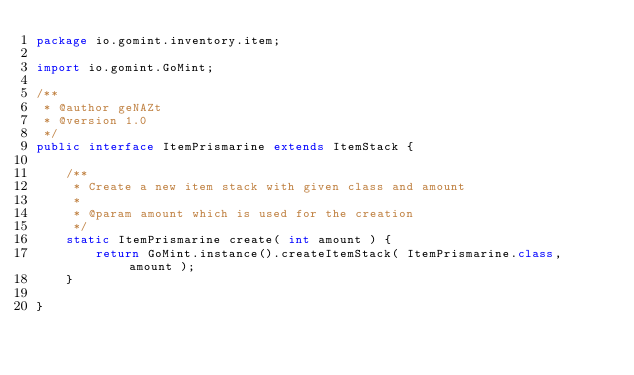Convert code to text. <code><loc_0><loc_0><loc_500><loc_500><_Java_>package io.gomint.inventory.item;

import io.gomint.GoMint;

/**
 * @author geNAZt
 * @version 1.0
 */
public interface ItemPrismarine extends ItemStack {

    /**
     * Create a new item stack with given class and amount
     *
     * @param amount which is used for the creation
     */
    static ItemPrismarine create( int amount ) {
        return GoMint.instance().createItemStack( ItemPrismarine.class, amount );
    }

}</code> 